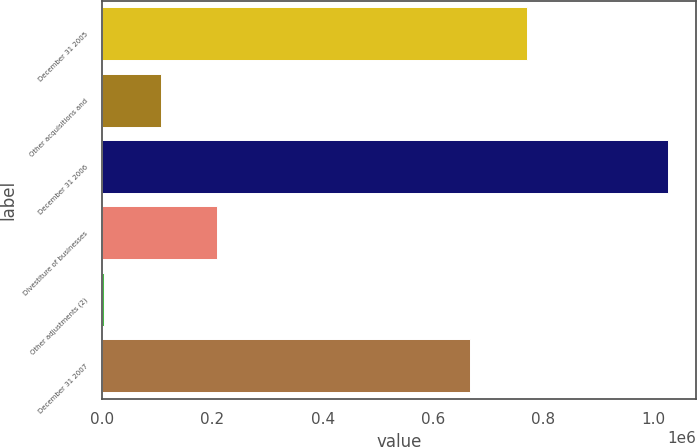<chart> <loc_0><loc_0><loc_500><loc_500><bar_chart><fcel>December 31 2005<fcel>Other acquisitions and<fcel>December 31 2006<fcel>Divestiture of businesses<fcel>Other adjustments (2)<fcel>December 31 2007<nl><fcel>770092<fcel>105791<fcel>1.0267e+06<fcel>208115<fcel>3468<fcel>667769<nl></chart> 